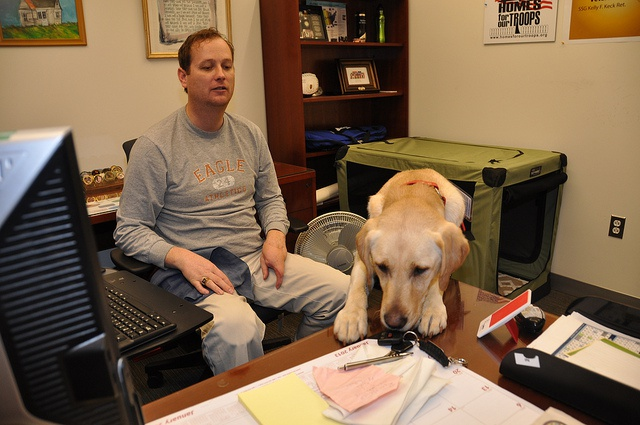Describe the objects in this image and their specific colors. I can see people in gray, tan, and black tones, tv in gray, black, and darkgray tones, dog in gray and tan tones, keyboard in gray, black, maroon, and tan tones, and chair in gray, black, and tan tones in this image. 